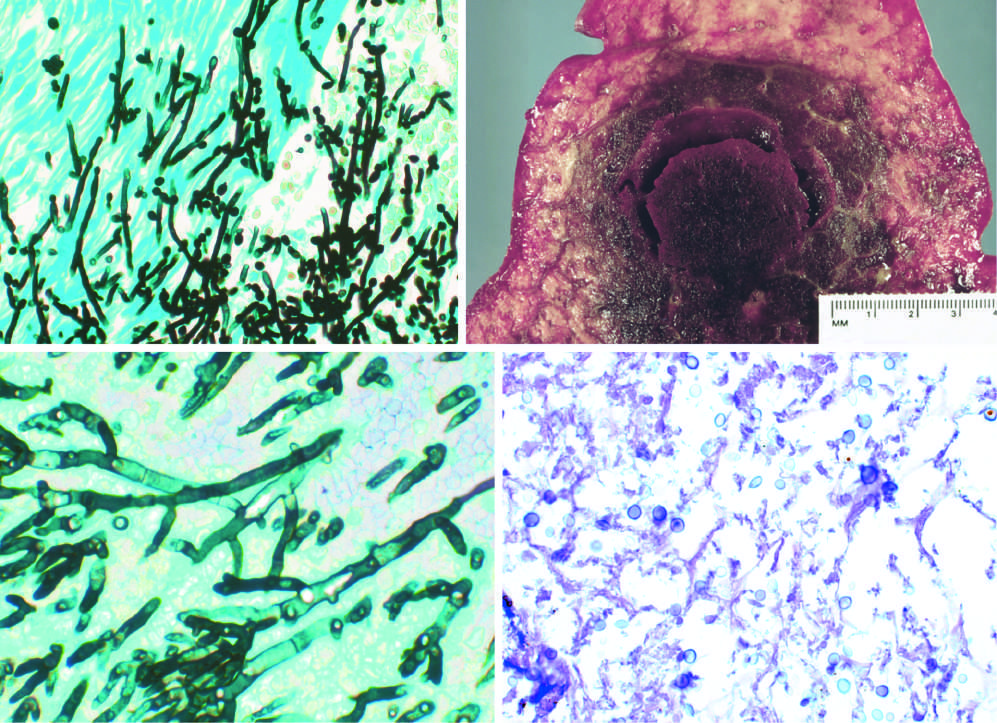does candida organism have pseudohyphae and budding yeasts silver stain?
Answer the question using a single word or phrase. Yes 